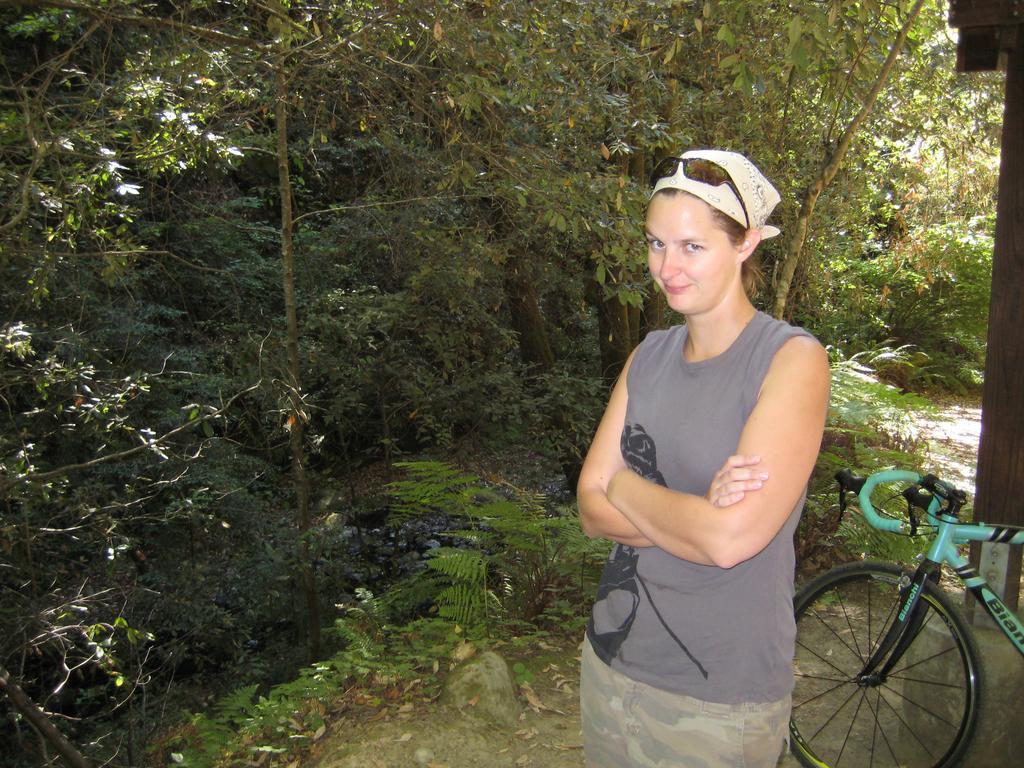How would you summarize this image in a sentence or two? In this picture we can see a woman standing, side we can see bicycle and behind we can see some trees, plants. 